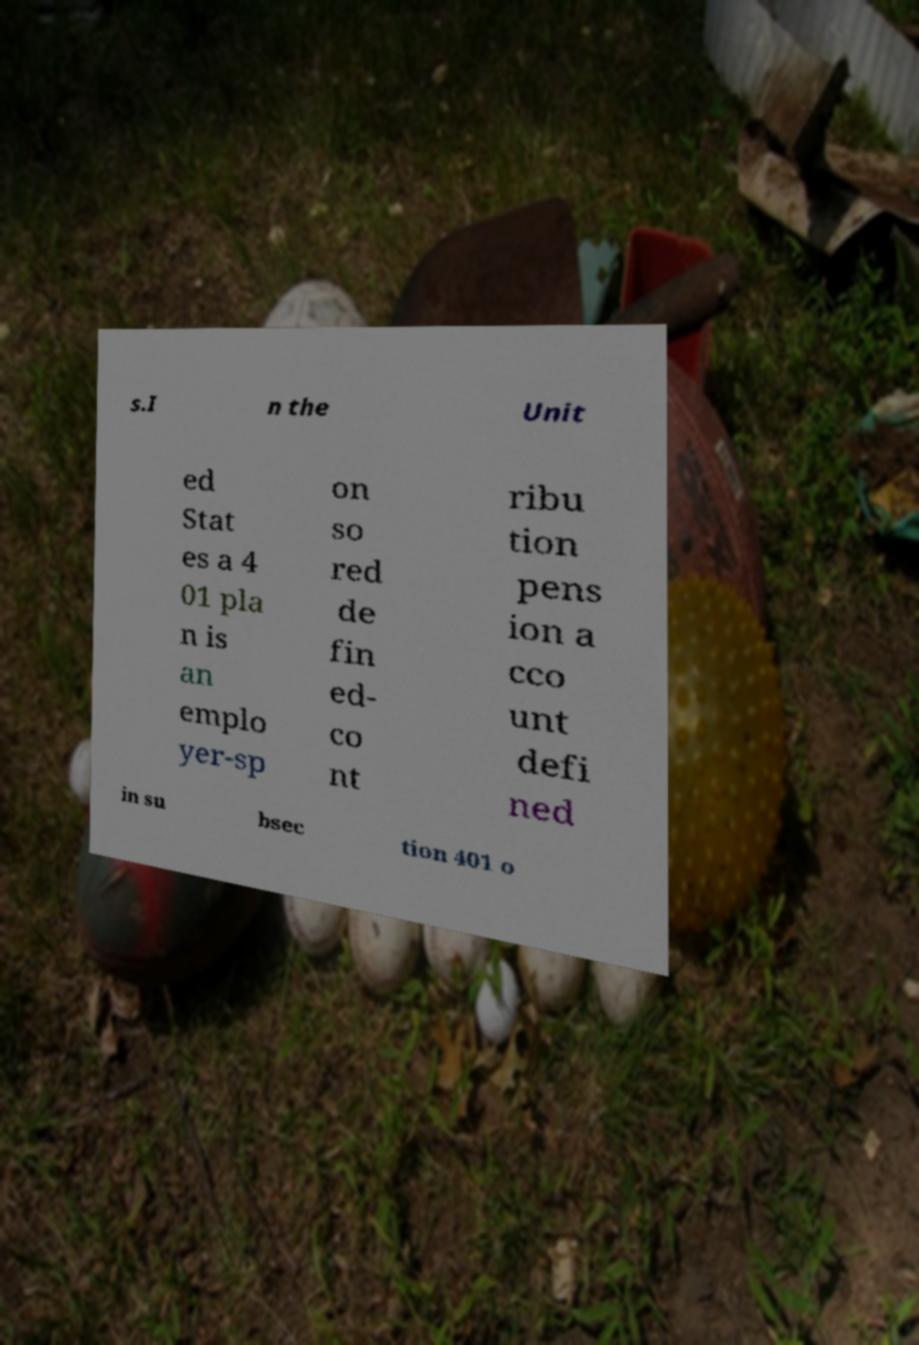Can you accurately transcribe the text from the provided image for me? s.I n the Unit ed Stat es a 4 01 pla n is an emplo yer-sp on so red de fin ed- co nt ribu tion pens ion a cco unt defi ned in su bsec tion 401 o 